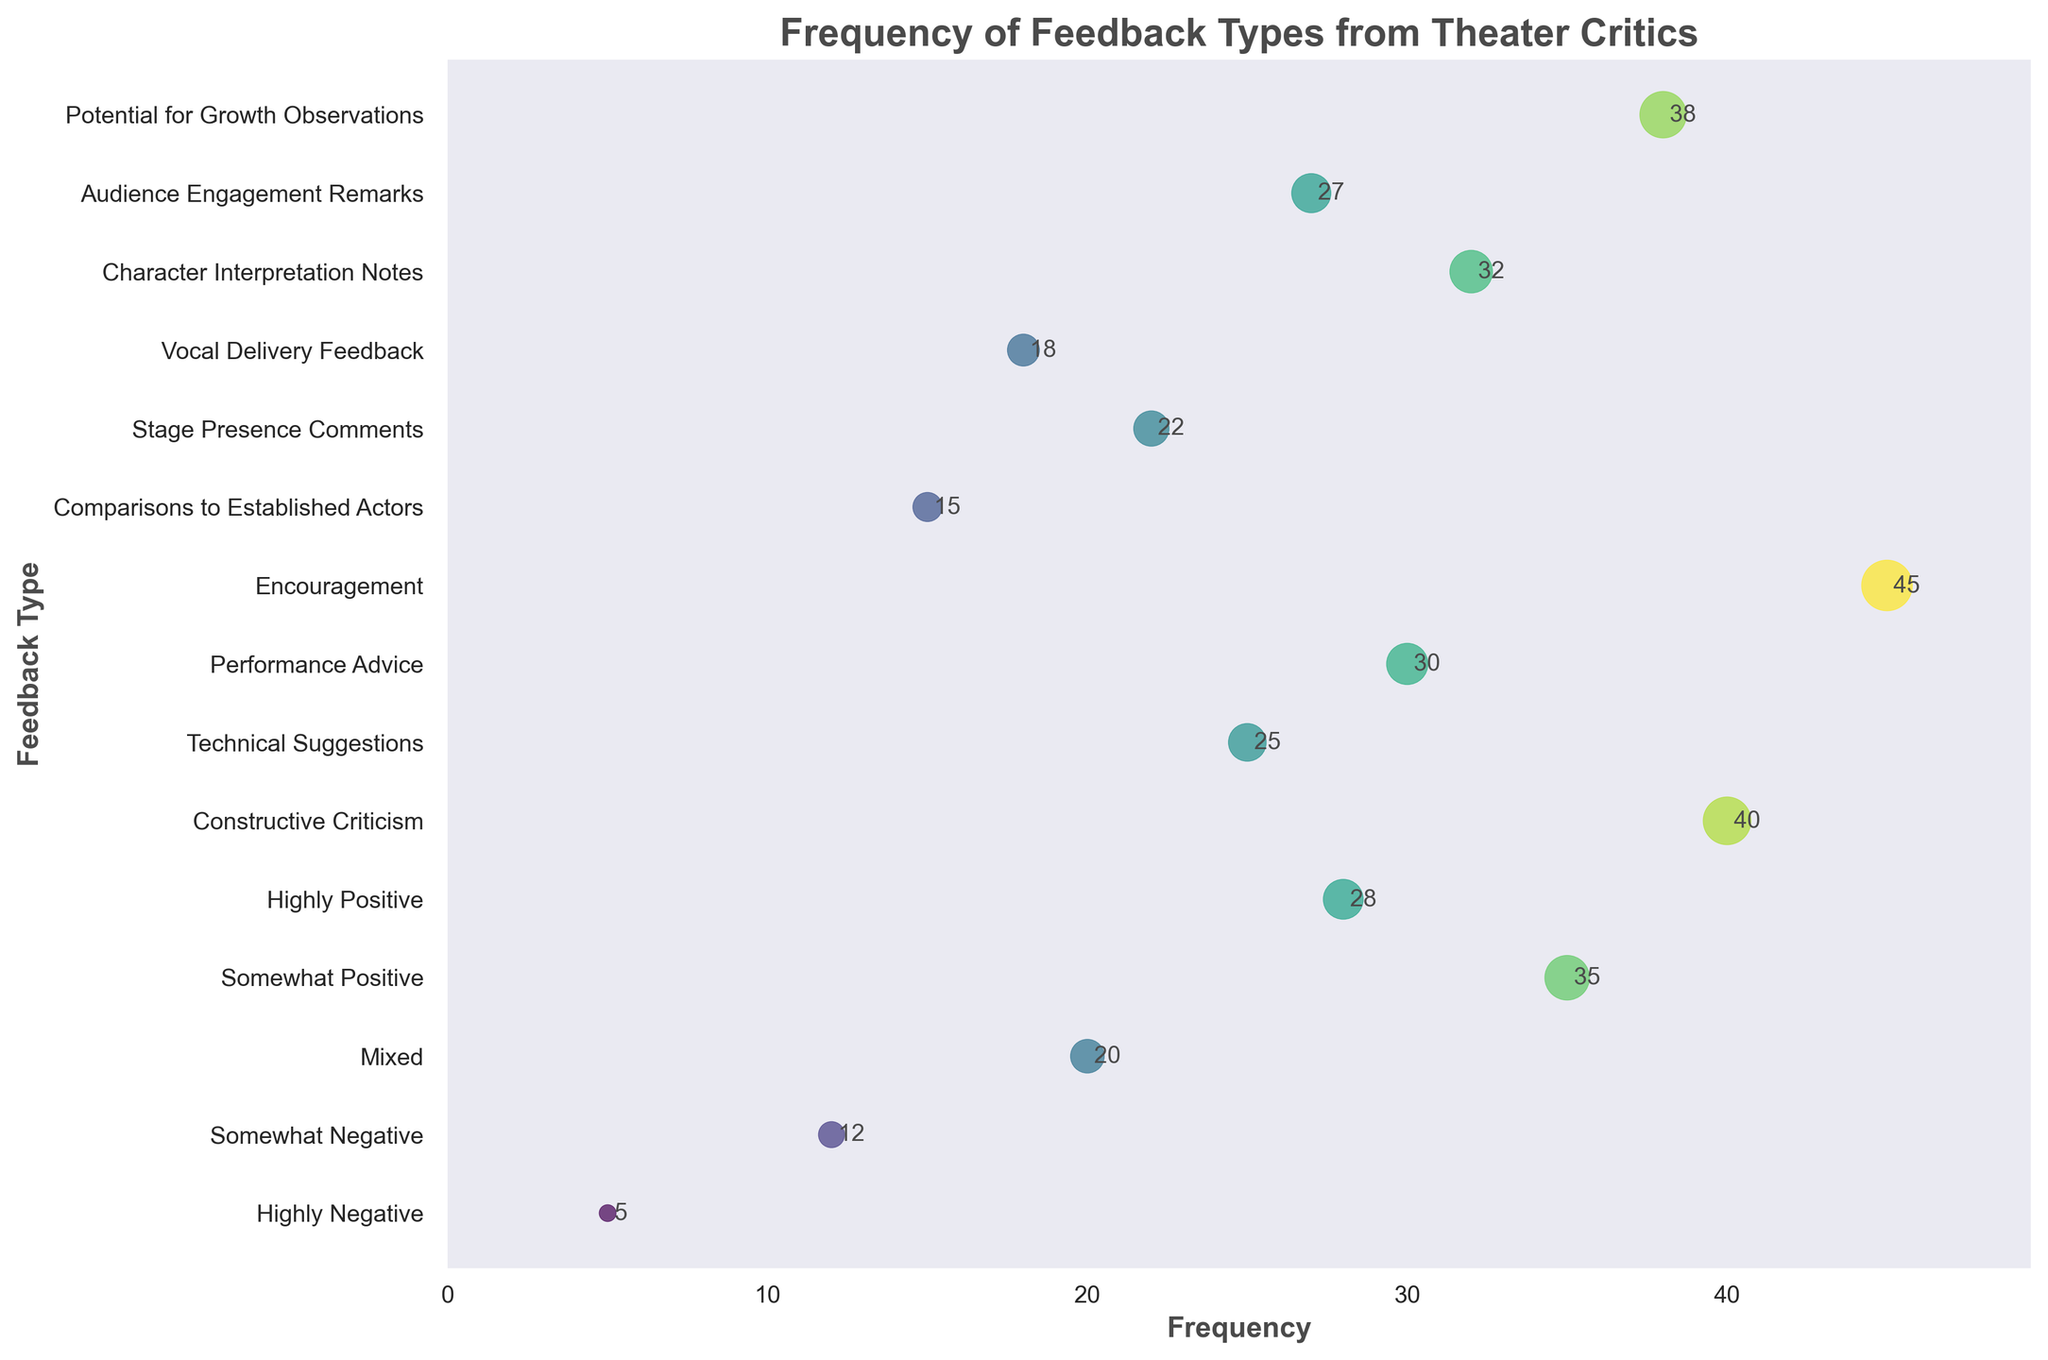What is the title of the figure? The title of the figure is displayed at the top and summarizes what the plot is about. By looking at the top of the plot, you can find the title easily.
Answer: Frequency of Feedback Types from Theater Critics Which feedback type has the highest frequency? By observing the scatter plot, you notice the data point with the highest value on the x-axis corresponds to the feedback type labeled "Encouragement".
Answer: Encouragement How many feedback types have a frequency greater than or equal to 30? Look at the x-axis values and count the data points where the frequency is 30 or more. These include "Somewhat Positive", "Highly Positive", "Performance Advice", "Character Interpretation Notes", "Audience Engagement Remarks", and "Potential for Growth Observations".
Answer: 6 Which feedback type has the lowest frequency? Identify the data point closest to the origin on the x-axis (leftmost position). The feedback type with the lowest frequency is "Highly Negative".
Answer: Highly Negative What is the sum of the frequencies for "Technical Suggestions" and "Vocal Delivery Feedback"? Find the frequencies for "Technical Suggestions" (25) and "Vocal Delivery Feedback" (18), then add them together (25 + 18).
Answer: 43 How does the frequency of "Constructive Criticism" compare to the frequency of "Comparisons to Established Actors"? "Constructive Criticism" has a frequency of 40, while "Comparisons to Established Actors" has a frequency of 15. Comparing these values shows that "Constructive Criticism" has a higher frequency.
Answer: Constructive Criticism has a higher frequency Which feedback type has a frequency that is twice that of "Highly Negative"? The frequency of "Highly Negative" is 5. The feedback type with a frequency twice that is "Somewhat Negative" with a frequency of 12.
Answer: Somewhat Negative Which feedback type is closest in frequency to "Stage Presence Comments"? Identify the frequency of "Stage Presence Comments" (22), then find the feedback type with a frequency closest to this value, which is "Vocal Delivery Feedback" (18).
Answer: Vocal Delivery Feedback Is "Potential for Growth Observations" more frequent than "Mixed"? Compare the frequencies of both feedback types: "Potential for Growth Observations" (38) and "Mixed" (20). "Potential for Growth Observations" has a higher frequency.
Answer: Yes By how much does the frequency of "Somewhat Positive" exceed "Somewhat Negative"? The frequency of "Somewhat Positive" is 35, and "Somewhat Negative" is 12. Subtract the smaller from the larger (35 - 12).
Answer: 23 